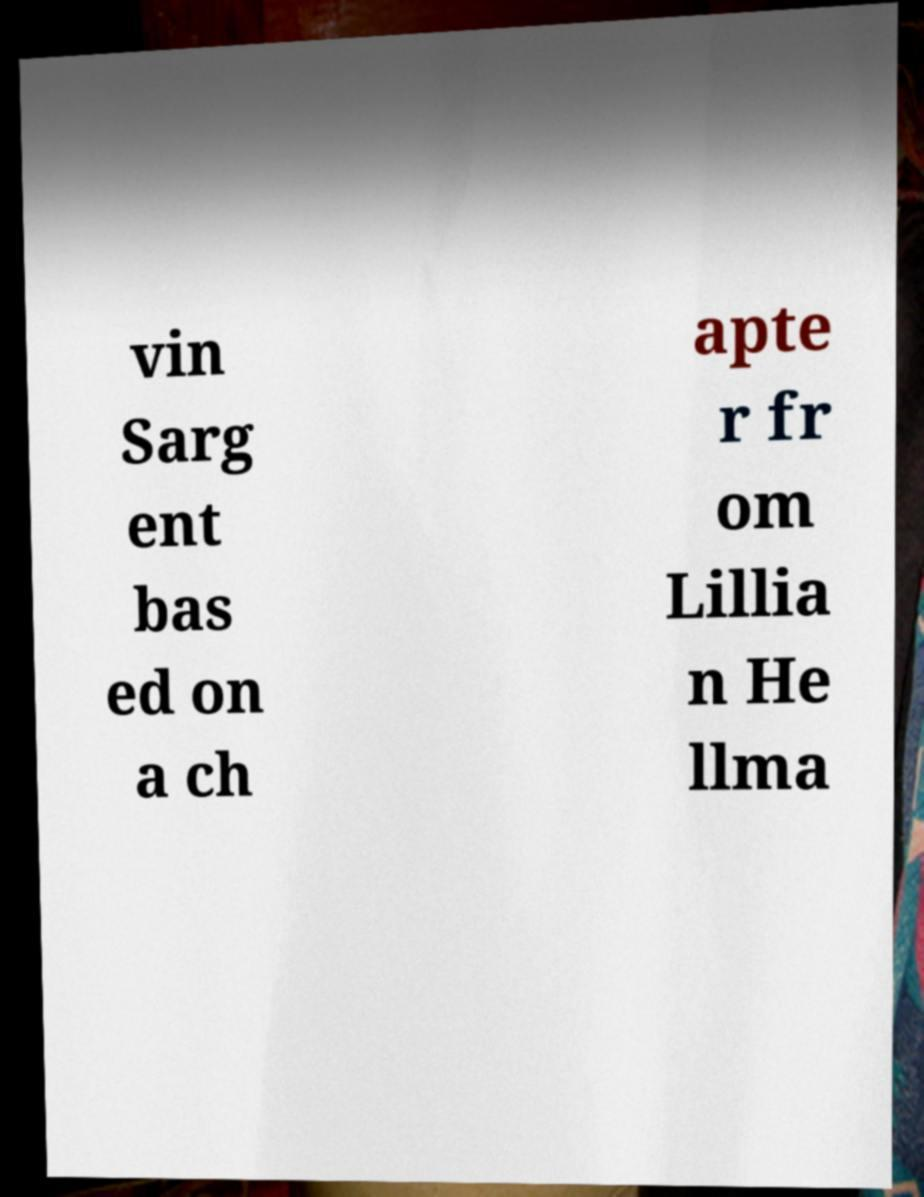Could you extract and type out the text from this image? vin Sarg ent bas ed on a ch apte r fr om Lillia n He llma 